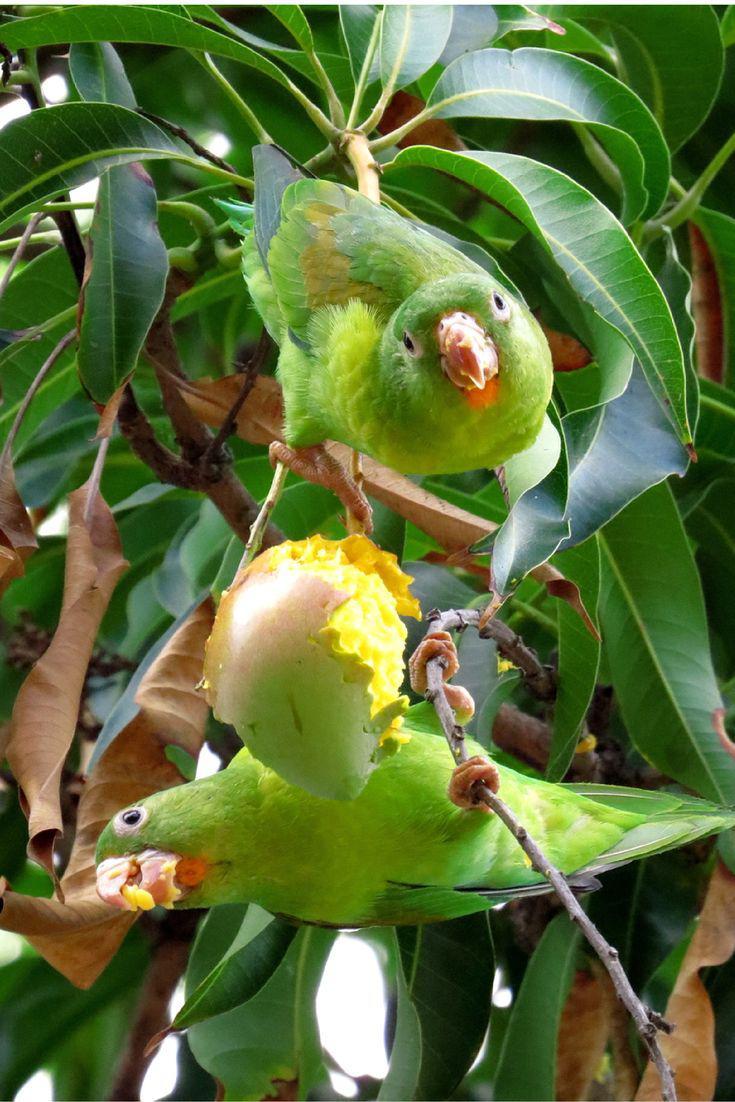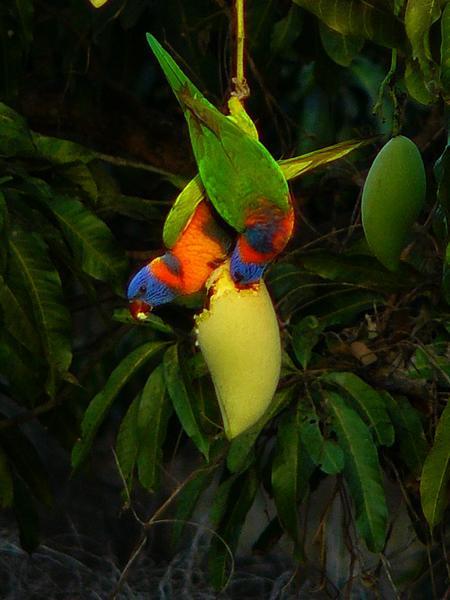The first image is the image on the left, the second image is the image on the right. Given the left and right images, does the statement "The right image shows a single toucan that has an orange beak and is upside down." hold true? Answer yes or no. No. The first image is the image on the left, the second image is the image on the right. For the images shown, is this caption "In the image on the right, a lone parrot/parakeet eats fruit, while hanging upside-down." true? Answer yes or no. No. 